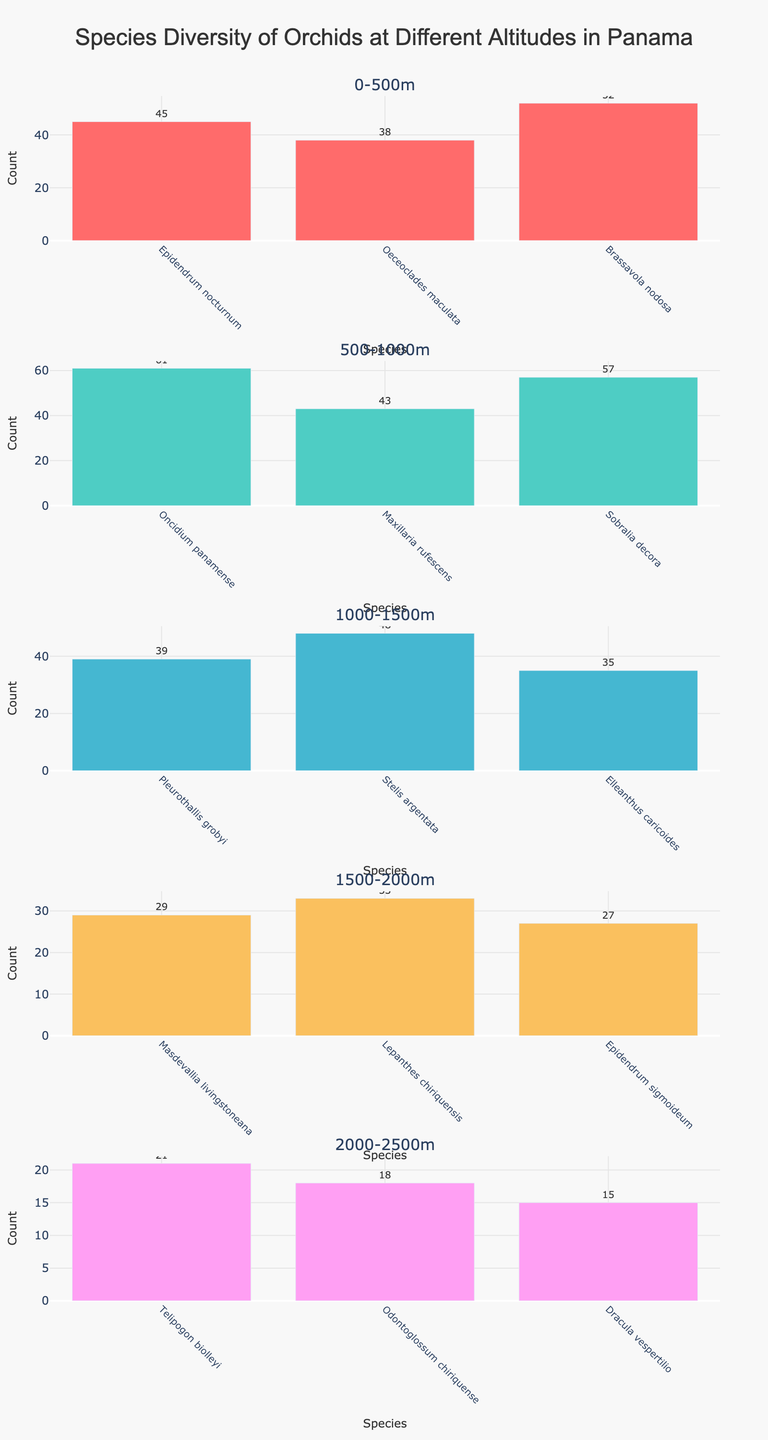What is the title of the figure? The title of the figure is usually displayed at the top and provides an overview of what the figure represents. In this case, it is about the diversity of orchid species in various altitudes in Panama.
Answer: Species Diversity of Orchids at Different Altitudes in Panama Which altitude range has the highest species count? To determine this, refer to the bars in each subplot and find the one with the highest value on the y-axis.
Answer: 500-1000m Among all altitudes, which orchid species has the lowest count? Look for the shortest bar across all subplots. Compare all the species counts to identify the smallest one.
Answer: Dracula vespertilio How many species are represented in the altitude range 1000-1500m? Count the bars in the subplot labeled with the altitude range 1000-1500m.
Answer: 3 What is the total species count for the altitude range 0-500m? Add up the counts of all species in the 0-500m altitude range: 45 (Epidendrum nocturnum) + 38 (Oeceoclades maculata) + 52 (Brassavola nodosa) = 135.
Answer: 135 Which species at the 500-1000m altitude has the highest count? Within the subplot for 500-1000m, identify the species with the tallest bar.
Answer: Oncidium panamense Compare the species counts of Brassavola nodosa and Dracula vespertilio. Which is higher and by how much? Identify the counts of Brassavola nodosa and Dracula vespertilio, then calculate the difference. Brassavola nodosa (52) – Dracula vespertilio (15) = 37.
Answer: Brassavola nodosa by 37 What is the average species count for the altitude range 1500-2000m? Sum up the counts for 1500-2000m and divide by the number of species: (29 + 33 + 27) / 3 ≈ 29.67.
Answer: 29.67 Is there any altitude range where all species have the same count? Check each subplot to see if all the bars within any subplot reach the same height.
Answer: No Which altitude range shows the most diversity in orchid species (highest number of species)? Count the number of different species (bars) in each altitude range's subplot.
Answer: 0-500m and 500-1000m (both have 3 species) 